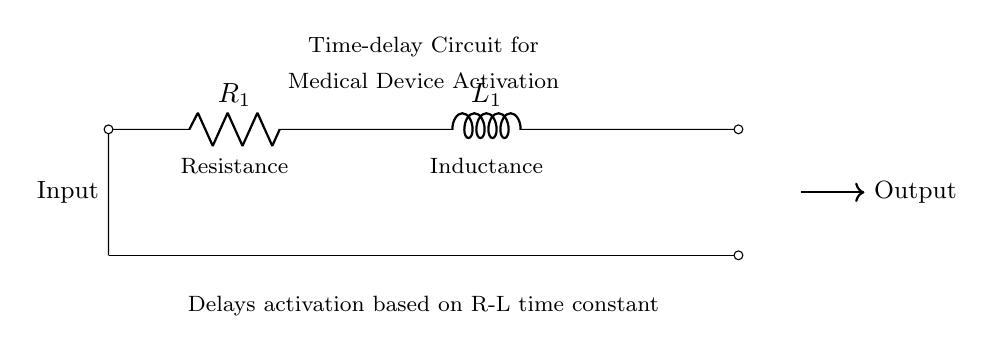What are the main components in this circuit? The main components are a resistor and an inductor. The resistor is labeled R1 and the inductor is labeled L1.
Answer: Resistor and Inductor What type of circuit is represented in the diagram? The circuit is a time-delay circuit that includes a resistor and an inductor, characteristic of a first-order R-L circuit used for delays.
Answer: Time-delay circuit What is the purpose of the time-delay feature in this circuit? The time-delay feature allows for the sequential activation of medical devices, ensuring that they are activated with a specific time interval determined by the resistor and inductor values.
Answer: Sequential activation Which component controls the delay in activation? The delay is controlled by the combination of the resistor and inductor. Their values together define the time constant which dictates the delay duration.
Answer: Resistor and Inductor What does the output of this circuit indicate? The output indicates when the medical device is activated following the delay created by the R-L time constant. It is represented by the arrow pointing to the output signal line.
Answer: Device activation signal How is the time constant determined in this circuit? The time constant is determined by the values of the resistor (R) and the inductance (L) and is calculated as the ratio L/R. This ratio dictates how quickly the circuit responds to an input.
Answer: L/R ratio 